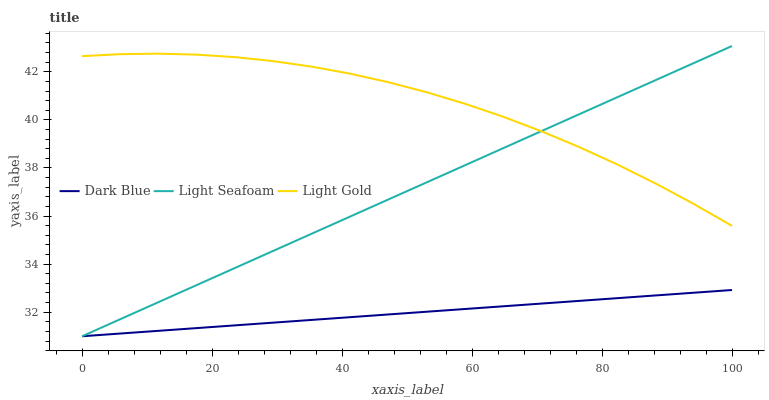Does Dark Blue have the minimum area under the curve?
Answer yes or no. Yes. Does Light Gold have the maximum area under the curve?
Answer yes or no. Yes. Does Light Seafoam have the minimum area under the curve?
Answer yes or no. No. Does Light Seafoam have the maximum area under the curve?
Answer yes or no. No. Is Dark Blue the smoothest?
Answer yes or no. Yes. Is Light Gold the roughest?
Answer yes or no. Yes. Is Light Seafoam the smoothest?
Answer yes or no. No. Is Light Seafoam the roughest?
Answer yes or no. No. Does Dark Blue have the lowest value?
Answer yes or no. Yes. Does Light Gold have the lowest value?
Answer yes or no. No. Does Light Seafoam have the highest value?
Answer yes or no. Yes. Does Light Gold have the highest value?
Answer yes or no. No. Is Dark Blue less than Light Gold?
Answer yes or no. Yes. Is Light Gold greater than Dark Blue?
Answer yes or no. Yes. Does Light Seafoam intersect Dark Blue?
Answer yes or no. Yes. Is Light Seafoam less than Dark Blue?
Answer yes or no. No. Is Light Seafoam greater than Dark Blue?
Answer yes or no. No. Does Dark Blue intersect Light Gold?
Answer yes or no. No. 